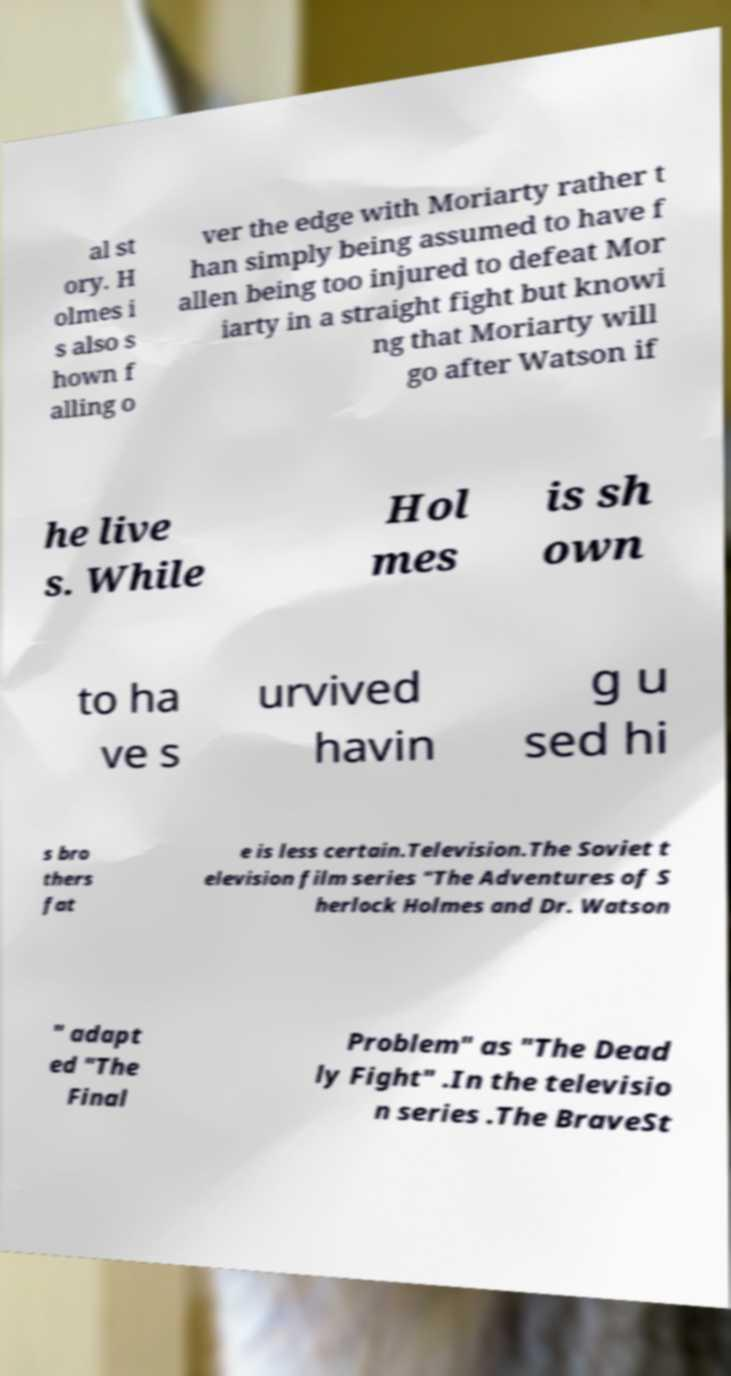Please identify and transcribe the text found in this image. al st ory. H olmes i s also s hown f alling o ver the edge with Moriarty rather t han simply being assumed to have f allen being too injured to defeat Mor iarty in a straight fight but knowi ng that Moriarty will go after Watson if he live s. While Hol mes is sh own to ha ve s urvived havin g u sed hi s bro thers fat e is less certain.Television.The Soviet t elevision film series "The Adventures of S herlock Holmes and Dr. Watson " adapt ed "The Final Problem" as "The Dead ly Fight" .In the televisio n series .The BraveSt 